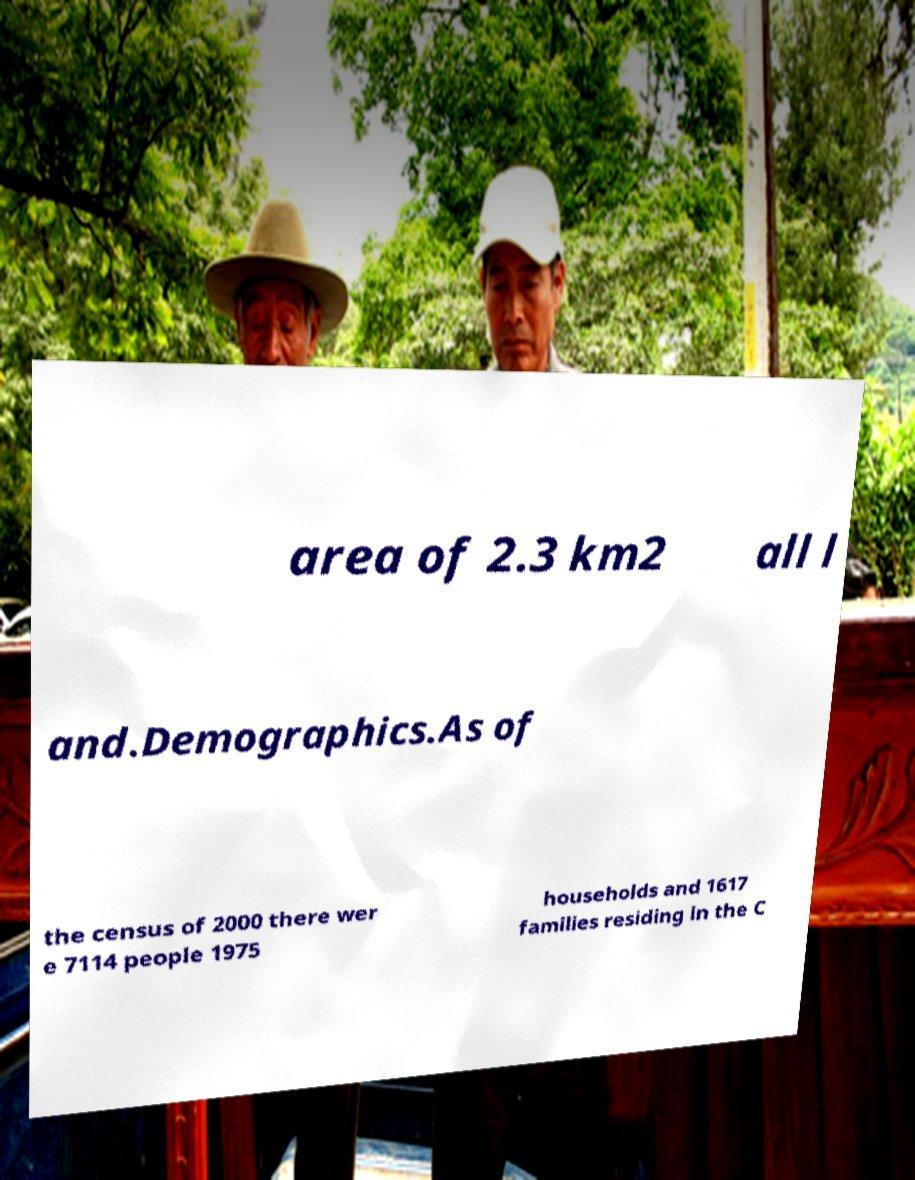Could you extract and type out the text from this image? area of 2.3 km2 all l and.Demographics.As of the census of 2000 there wer e 7114 people 1975 households and 1617 families residing in the C 